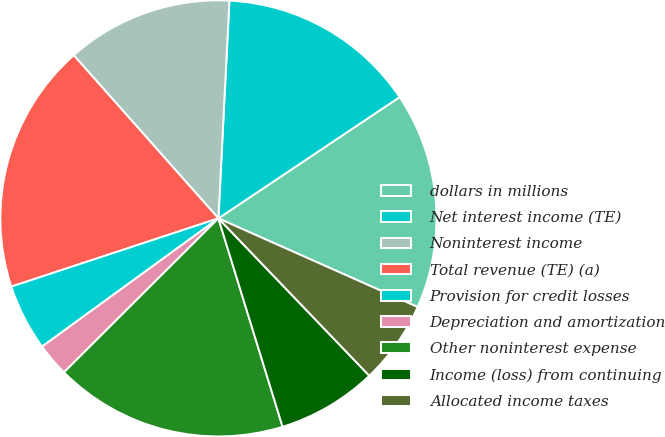Convert chart. <chart><loc_0><loc_0><loc_500><loc_500><pie_chart><fcel>dollars in millions<fcel>Net interest income (TE)<fcel>Noninterest income<fcel>Total revenue (TE) (a)<fcel>Provision for credit losses<fcel>Depreciation and amortization<fcel>Other noninterest expense<fcel>Income (loss) from continuing<fcel>Allocated income taxes<nl><fcel>16.05%<fcel>14.81%<fcel>12.35%<fcel>18.52%<fcel>4.94%<fcel>2.47%<fcel>17.28%<fcel>7.41%<fcel>6.17%<nl></chart> 